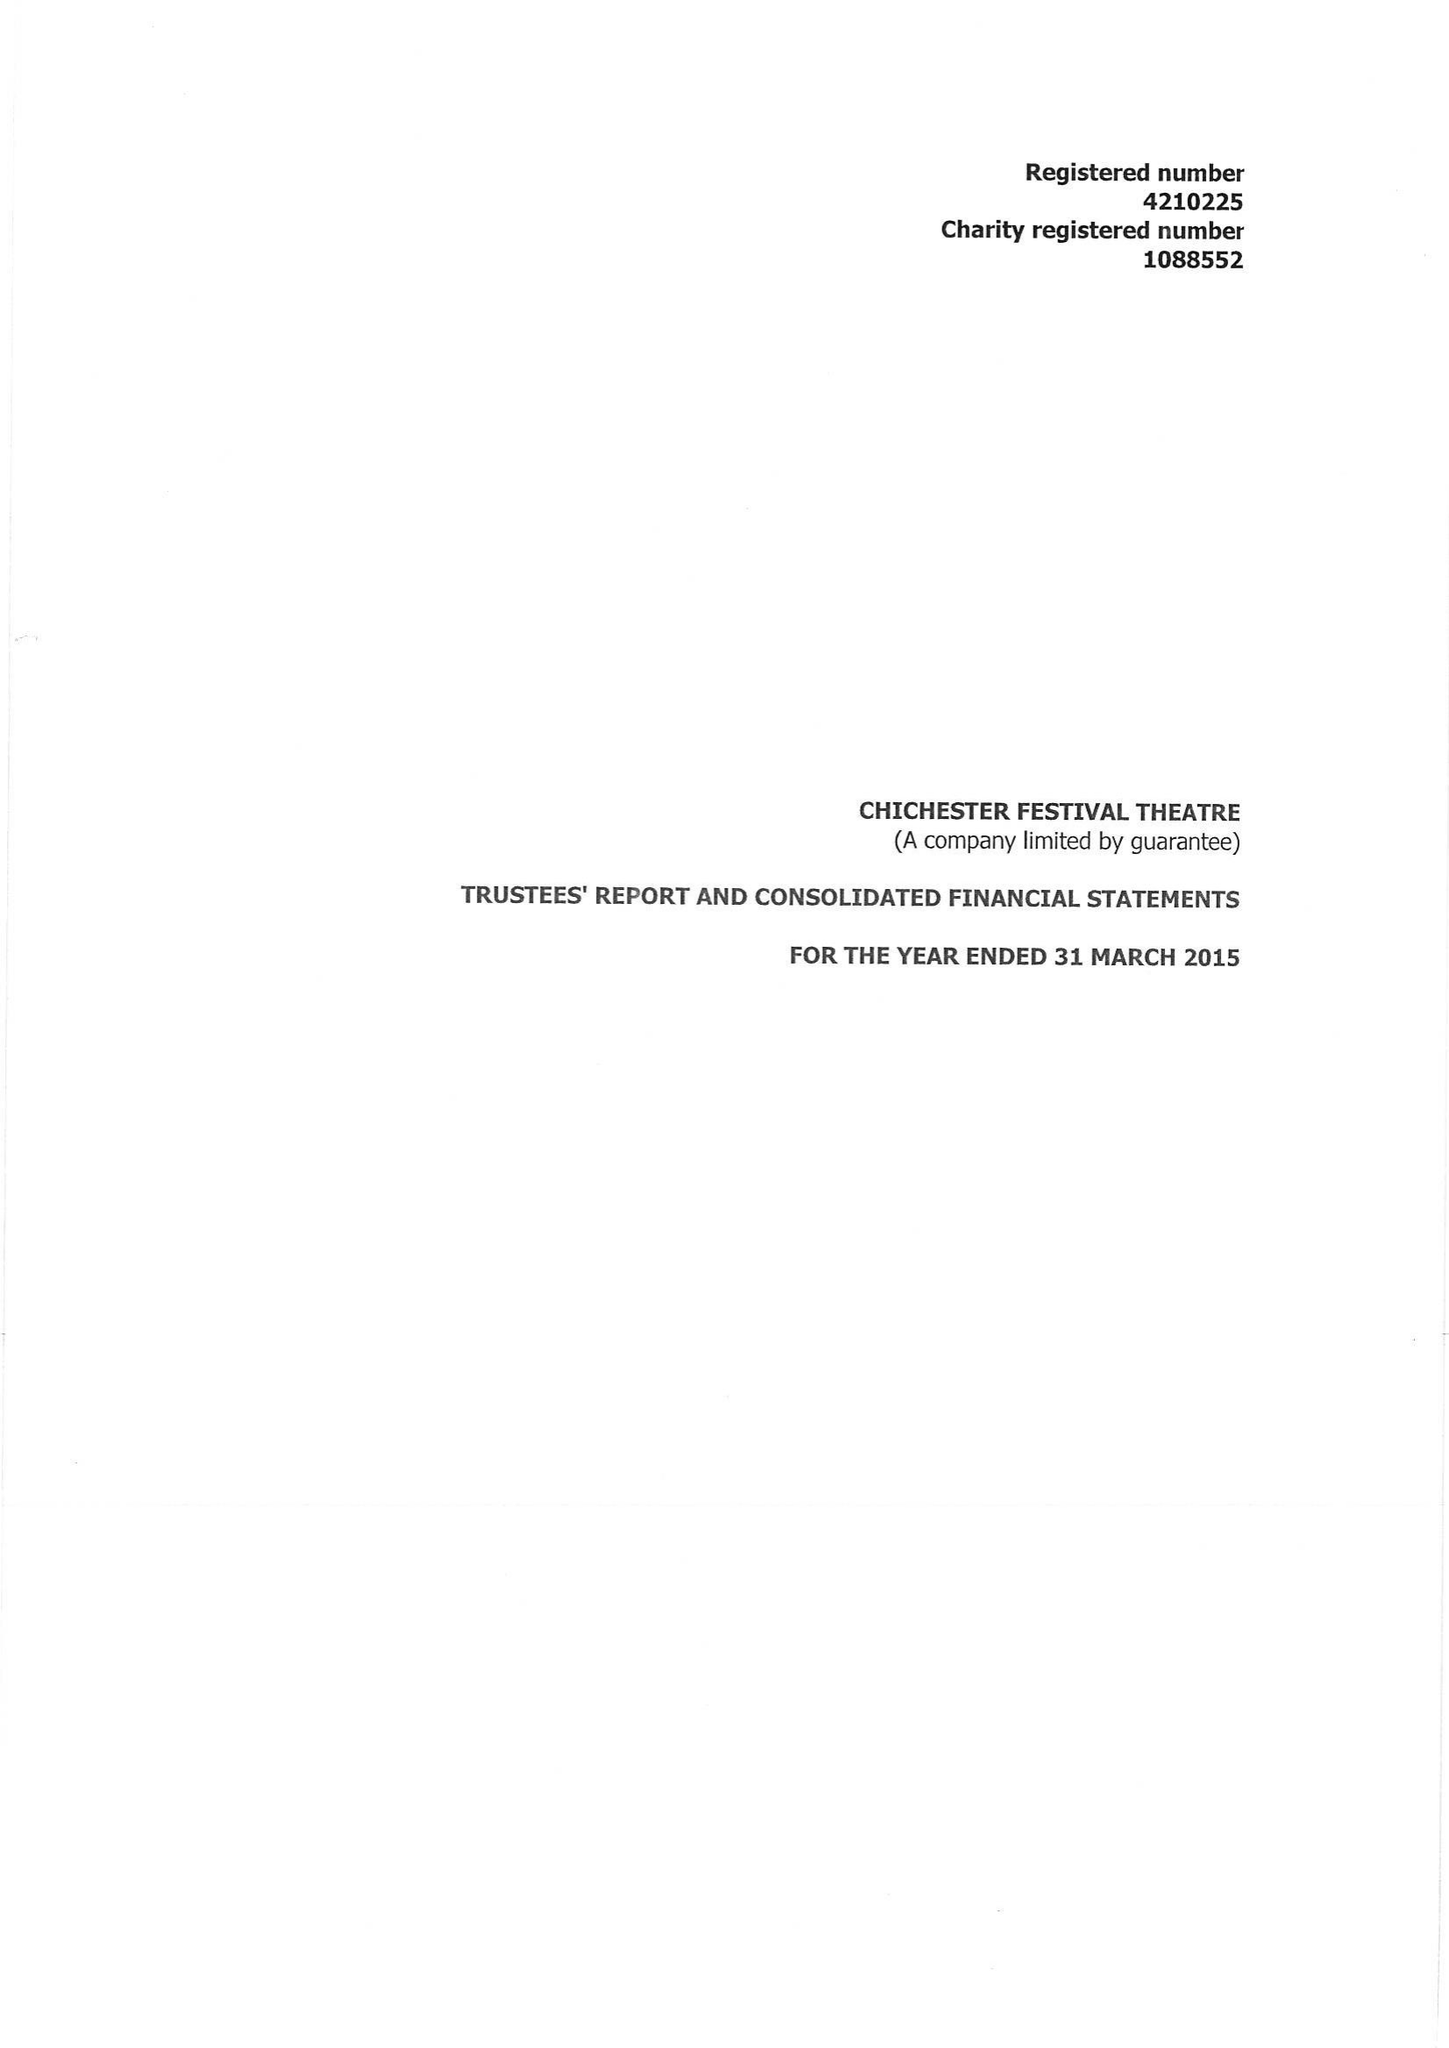What is the value for the charity_number?
Answer the question using a single word or phrase. 1088552 